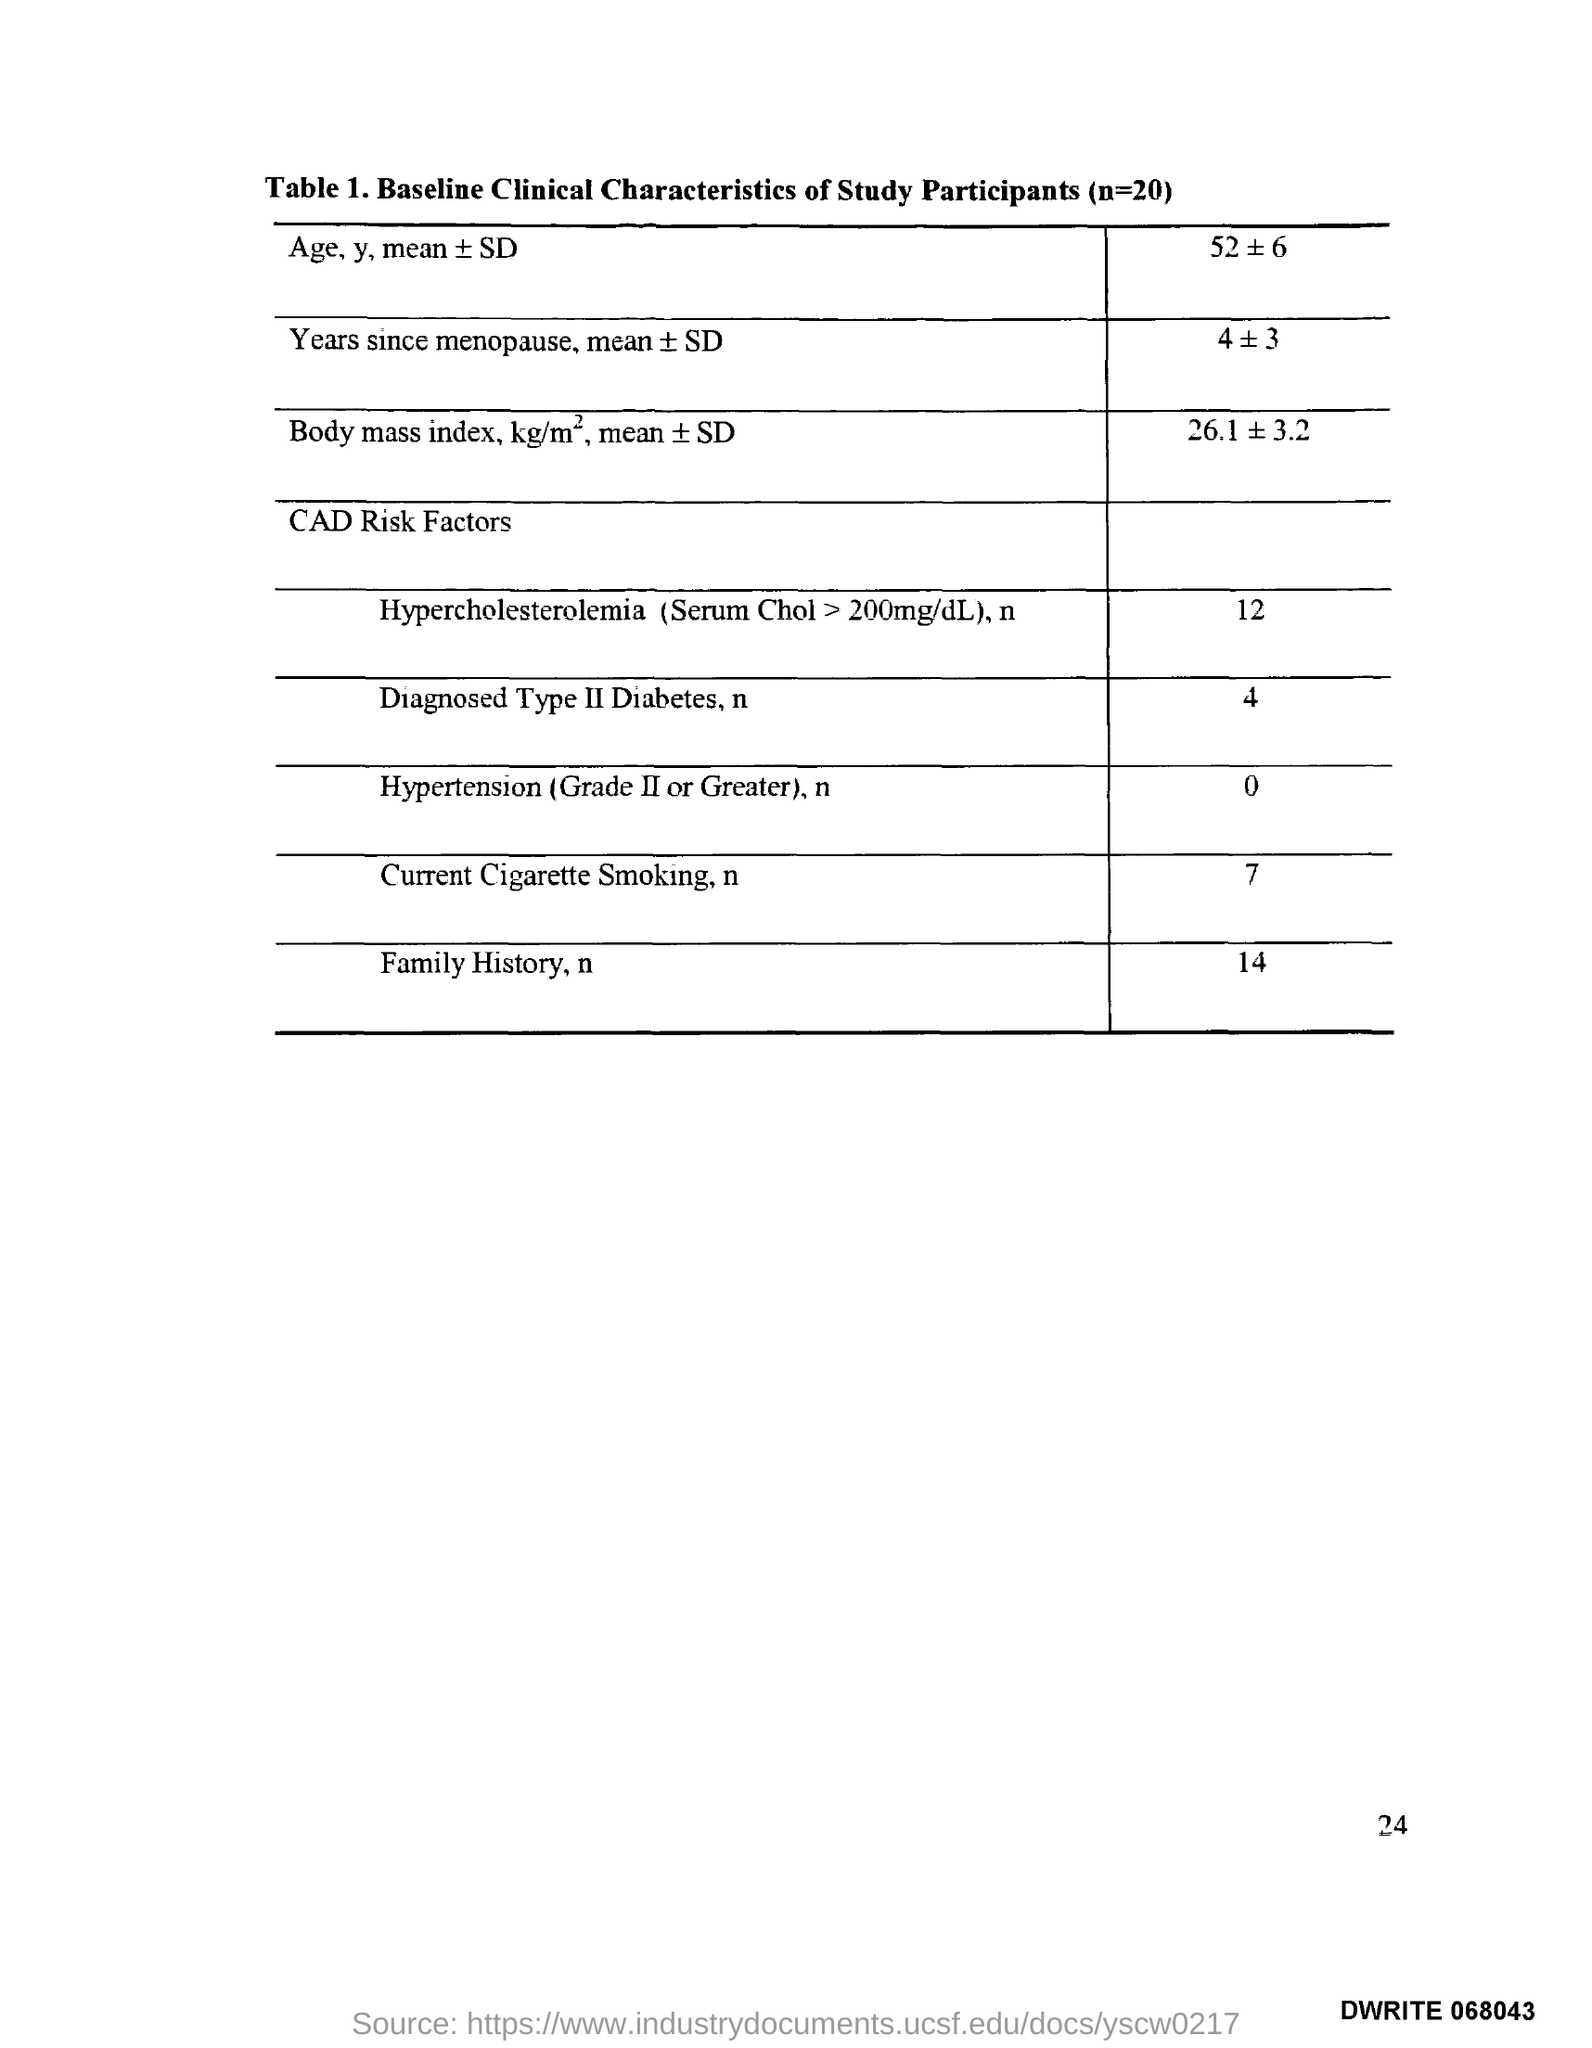What does Table 1. in this document describe?
Give a very brief answer. Baseline Clinical Characteristics of Study Participants (n=20). 